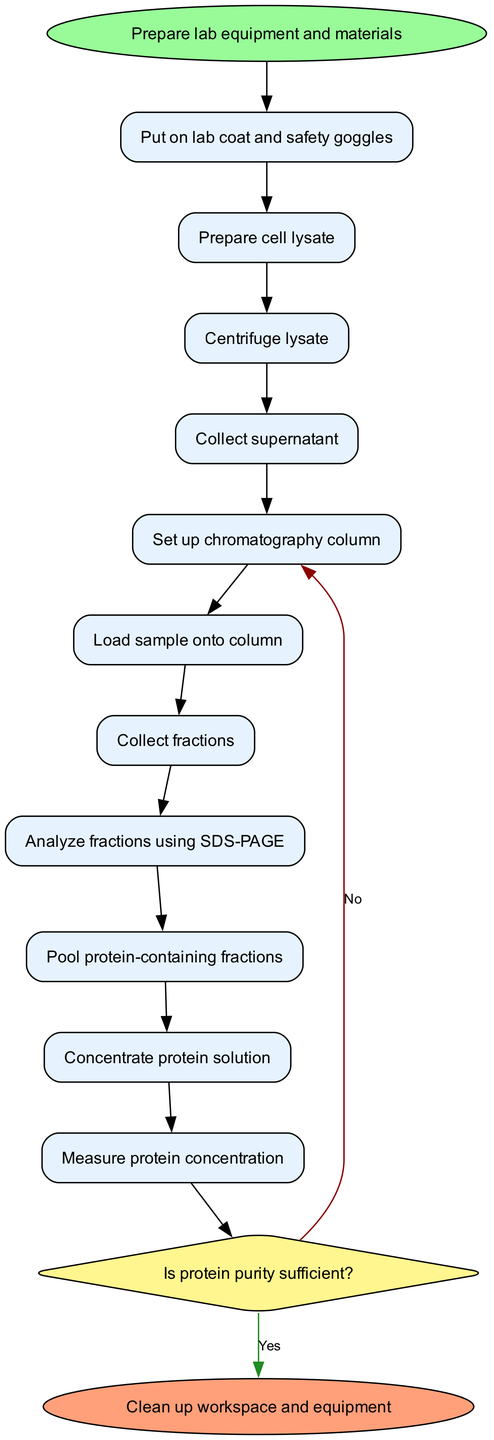What is the initial node in the workflow? The initial node is the starting point of the activity diagram, which is specified in the data under "initialNode". It states the first action to be taken in the experiment, which is "Prepare lab equipment and materials".
Answer: Prepare lab equipment and materials How many activity nodes are there in the diagram? The number of activity nodes is determined by counting the number of items listed under "activities". There are a total of 11 activities in the workflow outlined in the data.
Answer: 11 What is the final node of the process? The final node is the last action that concludes the workflow. It is indicated in the data as the "finalNode", which states "Clean up workspace and equipment".
Answer: Clean up workspace and equipment What action follows "Analyze fractions using SDS-PAGE"? To determine the action that comes after "Analyze fractions using SDS-PAGE", we can refer to the edges in the data. According to the edges listed, the next action is "Pool protein-containing fractions".
Answer: Pool protein-containing fractions What is the first decision made in the workflow? The first decision made in the workflow is represented by the decision node in the diagram, which asks the question "Is protein purity sufficient?". This node indicates a branching point where further actions depend on the answer.
Answer: Is protein purity sufficient? If the protein purity is insufficient, what step is taken next? If the protein purity is determined to be insufficient (answering "No" in the decision), the diagram specifies that the next step is "Perform additional purification step". This follows from the edge corresponding to the "No" answer in the decision.
Answer: Perform additional purification step How many edges connect the activities to the decision node? To find the number of edges that connect activities to the decision node, we can count the edges in the list that lead to the decision point from preceding activities. There are 1 edge from the last activity ("Measure protein concentration") to the decision node.
Answer: 1 What two actions could occur after analyzing the fractions? After the action "Analyze fractions using SDS-PAGE", two possible actions could occur depending on the outcome: either "Pool protein-containing fractions" if there is protein present or perform additional purification in the case of insufficient purity. However, the specific action cannot occur as it depends on the analysis result.
Answer: Pool protein-containing fractions, Perform additional purification step What is the relationship between "Collect supernatant" and "Set up chromatography column"? The relationship between the two actions can be established from the edges in the diagram. "Collect supernatant" directly leads to "Set up chromatography column", indicating that this is a sequential workflow where the second action follows the first.
Answer: Sequential relationship 